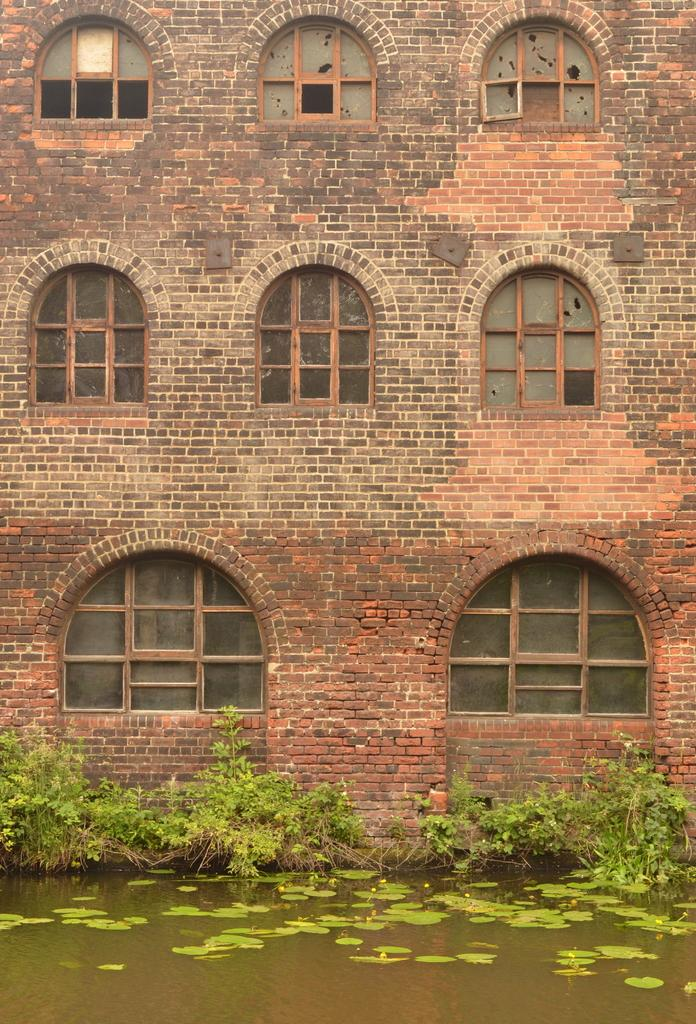What is visible in the image? Water is visible in the image. What can be seen in the background of the image? There are plants and a building in the background of the image. What color are the plants in the image? The plants are green in color. What color is the building in the image? The building is brown in color. What architectural feature can be seen on the building? There are windows visible on the building. What type of soda is being poured into the water in the image? There is no soda present in the image; it only features water, plants, and a building. How many leaves can be seen on the plants in the image? There is no mention of leaves on the plants in the image, only that they are green in color. 